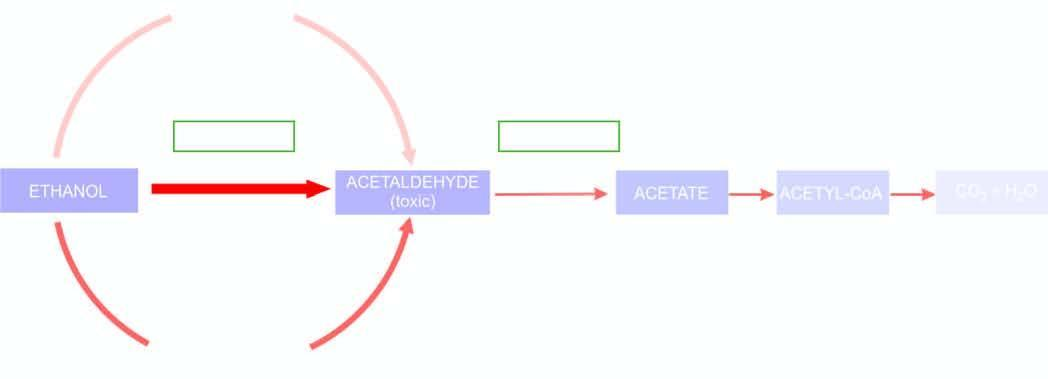do these nests correspond to extent of metabolic pathway followed adh = alcohol dehydrogenase ; aldh or acdh = hepatic acetaldehyde dehydrogenase ; nad = nicotinamide adenine dinucleotide ; nadh = reduced nad?
Answer the question using a single word or phrase. No 